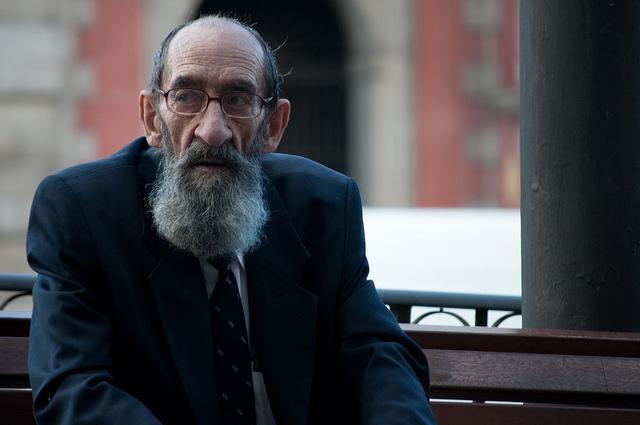What color is the jacket blazer worn by the man with the beard?
Choose the right answer from the provided options to respond to the question.
Options: White, yellow, red, blue. Blue. 